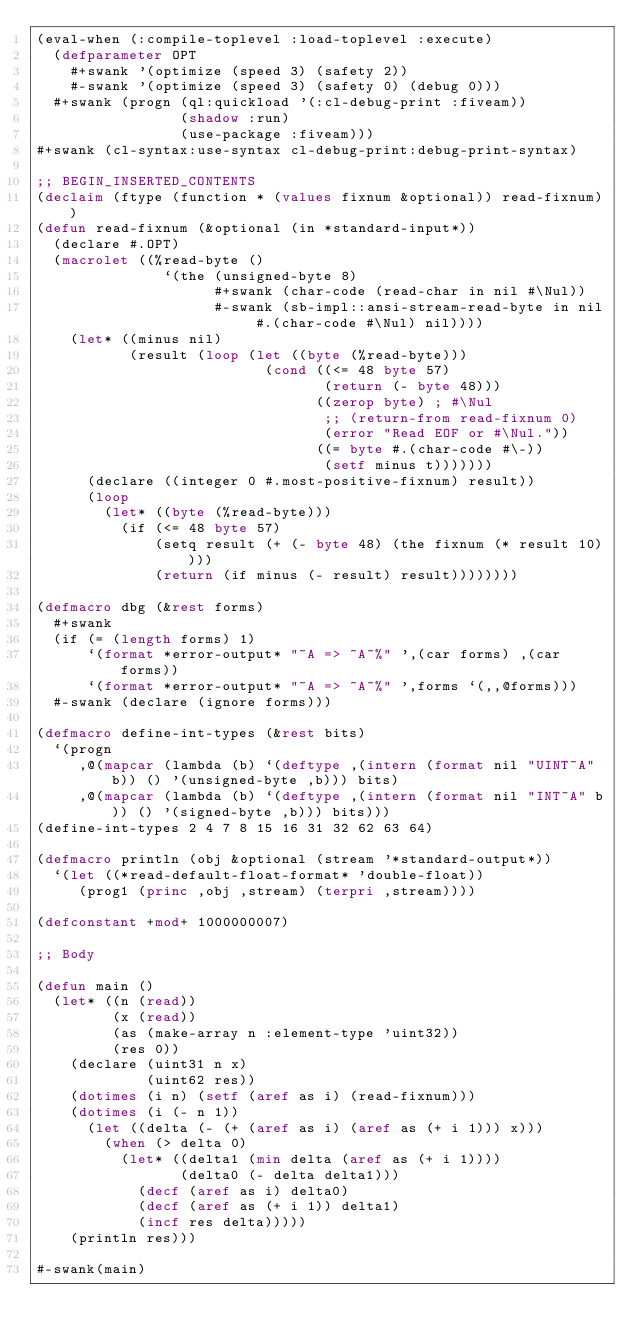Convert code to text. <code><loc_0><loc_0><loc_500><loc_500><_Lisp_>(eval-when (:compile-toplevel :load-toplevel :execute)
  (defparameter OPT
    #+swank '(optimize (speed 3) (safety 2))
    #-swank '(optimize (speed 3) (safety 0) (debug 0)))
  #+swank (progn (ql:quickload '(:cl-debug-print :fiveam))
                 (shadow :run)
                 (use-package :fiveam)))
#+swank (cl-syntax:use-syntax cl-debug-print:debug-print-syntax)

;; BEGIN_INSERTED_CONTENTS
(declaim (ftype (function * (values fixnum &optional)) read-fixnum))
(defun read-fixnum (&optional (in *standard-input*))
  (declare #.OPT)
  (macrolet ((%read-byte ()
               `(the (unsigned-byte 8)
                     #+swank (char-code (read-char in nil #\Nul))
                     #-swank (sb-impl::ansi-stream-read-byte in nil #.(char-code #\Nul) nil))))
    (let* ((minus nil)
           (result (loop (let ((byte (%read-byte)))
                           (cond ((<= 48 byte 57)
                                  (return (- byte 48)))
                                 ((zerop byte) ; #\Nul
                                  ;; (return-from read-fixnum 0)
                                  (error "Read EOF or #\Nul."))
                                 ((= byte #.(char-code #\-))
                                  (setf minus t)))))))
      (declare ((integer 0 #.most-positive-fixnum) result))
      (loop
        (let* ((byte (%read-byte)))
          (if (<= 48 byte 57)
              (setq result (+ (- byte 48) (the fixnum (* result 10))))
              (return (if minus (- result) result))))))))

(defmacro dbg (&rest forms)
  #+swank
  (if (= (length forms) 1)
      `(format *error-output* "~A => ~A~%" ',(car forms) ,(car forms))
      `(format *error-output* "~A => ~A~%" ',forms `(,,@forms)))
  #-swank (declare (ignore forms)))

(defmacro define-int-types (&rest bits)
  `(progn
     ,@(mapcar (lambda (b) `(deftype ,(intern (format nil "UINT~A" b)) () '(unsigned-byte ,b))) bits)
     ,@(mapcar (lambda (b) `(deftype ,(intern (format nil "INT~A" b)) () '(signed-byte ,b))) bits)))
(define-int-types 2 4 7 8 15 16 31 32 62 63 64)

(defmacro println (obj &optional (stream '*standard-output*))
  `(let ((*read-default-float-format* 'double-float))
     (prog1 (princ ,obj ,stream) (terpri ,stream))))

(defconstant +mod+ 1000000007)

;; Body

(defun main ()
  (let* ((n (read))
         (x (read))
         (as (make-array n :element-type 'uint32))
         (res 0))
    (declare (uint31 n x)
             (uint62 res))
    (dotimes (i n) (setf (aref as i) (read-fixnum)))
    (dotimes (i (- n 1))
      (let ((delta (- (+ (aref as i) (aref as (+ i 1))) x)))
        (when (> delta 0)
          (let* ((delta1 (min delta (aref as (+ i 1))))
                 (delta0 (- delta delta1)))
            (decf (aref as i) delta0)
            (decf (aref as (+ i 1)) delta1)
            (incf res delta)))))
    (println res)))

#-swank(main)
</code> 